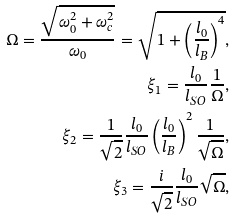Convert formula to latex. <formula><loc_0><loc_0><loc_500><loc_500>\Omega = \frac { \sqrt { \omega _ { 0 } ^ { 2 } + \omega _ { c } ^ { 2 } } } { \omega _ { 0 } } = \sqrt { 1 + \left ( \frac { l _ { 0 } } { l _ { B } } \right ) ^ { 4 } } , \\ \xi _ { 1 } = \frac { l _ { 0 } } { l _ { S O } } \frac { 1 } { \Omega } , \\ \xi _ { 2 } = \frac { 1 } { \sqrt { 2 } } \frac { l _ { 0 } } { l _ { S O } } \left ( \frac { l _ { 0 } } { l _ { B } } \right ) ^ { 2 } \frac { 1 } { \sqrt { \Omega } } , \\ \xi _ { 3 } = \frac { i } { \sqrt { 2 } } \frac { l _ { 0 } } { l _ { S O } } \sqrt { \Omega } ,</formula> 